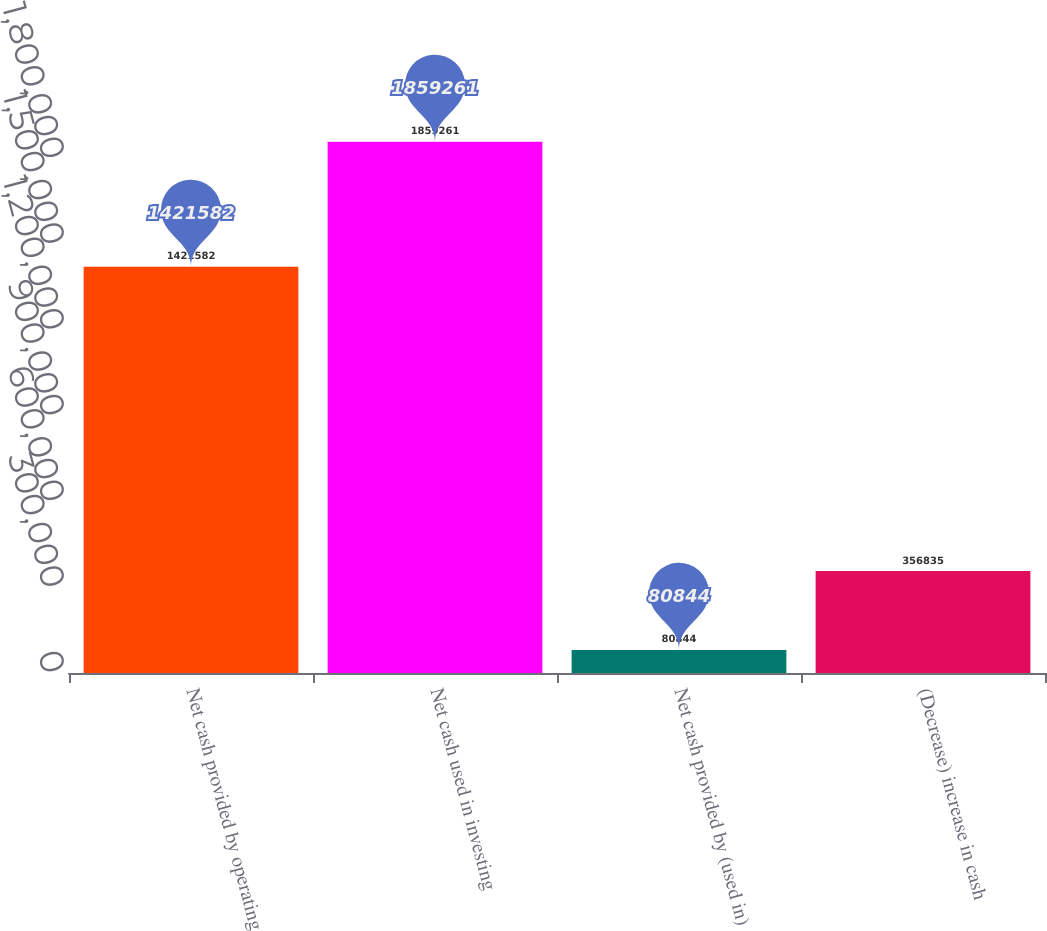Convert chart. <chart><loc_0><loc_0><loc_500><loc_500><bar_chart><fcel>Net cash provided by operating<fcel>Net cash used in investing<fcel>Net cash provided by (used in)<fcel>(Decrease) increase in cash<nl><fcel>1.42158e+06<fcel>1.85926e+06<fcel>80844<fcel>356835<nl></chart> 